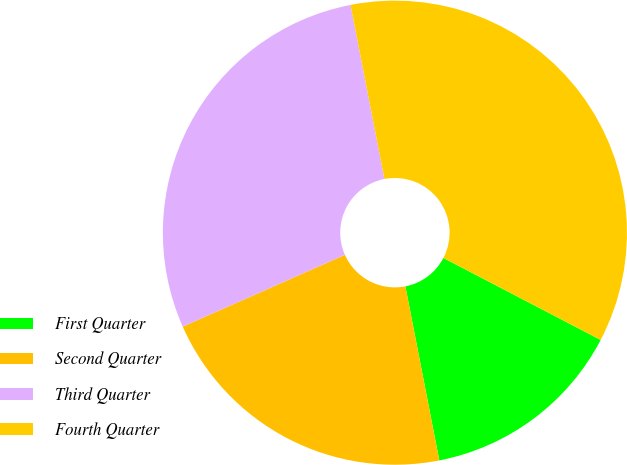Convert chart to OTSL. <chart><loc_0><loc_0><loc_500><loc_500><pie_chart><fcel>First Quarter<fcel>Second Quarter<fcel>Third Quarter<fcel>Fourth Quarter<nl><fcel>14.29%<fcel>21.43%<fcel>28.57%<fcel>35.71%<nl></chart> 